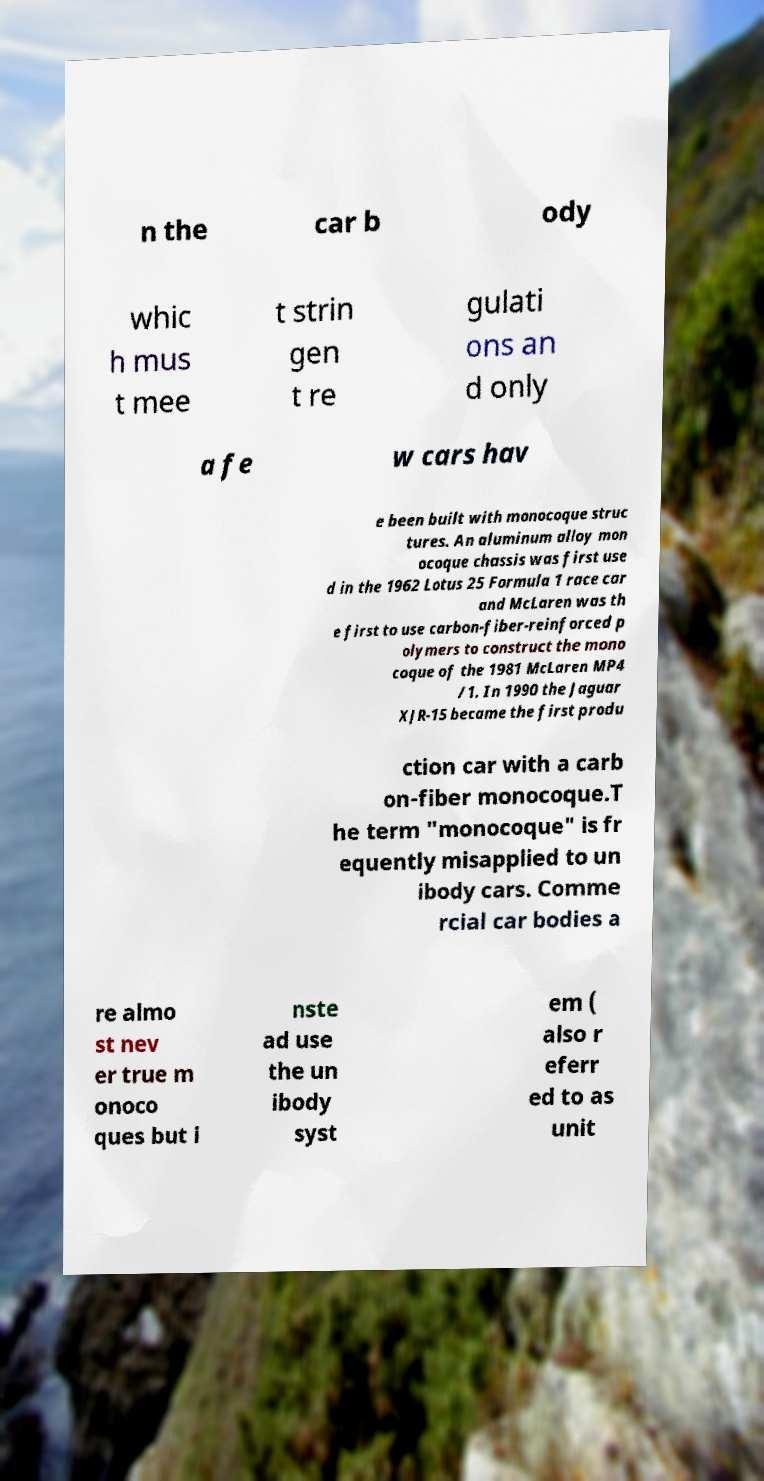Please identify and transcribe the text found in this image. n the car b ody whic h mus t mee t strin gen t re gulati ons an d only a fe w cars hav e been built with monocoque struc tures. An aluminum alloy mon ocoque chassis was first use d in the 1962 Lotus 25 Formula 1 race car and McLaren was th e first to use carbon-fiber-reinforced p olymers to construct the mono coque of the 1981 McLaren MP4 /1. In 1990 the Jaguar XJR-15 became the first produ ction car with a carb on-fiber monocoque.T he term "monocoque" is fr equently misapplied to un ibody cars. Comme rcial car bodies a re almo st nev er true m onoco ques but i nste ad use the un ibody syst em ( also r eferr ed to as unit 